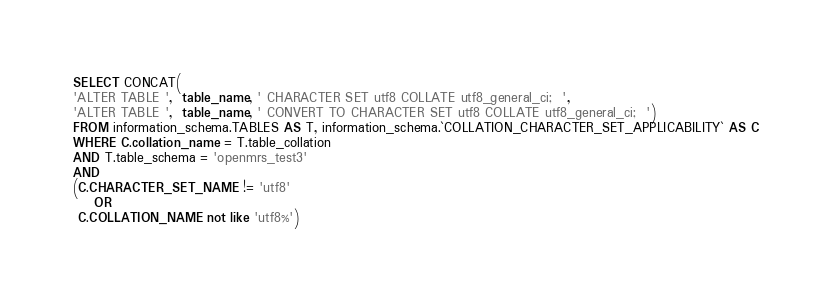<code> <loc_0><loc_0><loc_500><loc_500><_SQL_>SELECT CONCAT(
'ALTER TABLE ',  table_name, ' CHARACTER SET utf8 COLLATE utf8_general_ci;  ', 
'ALTER TABLE ',  table_name, ' CONVERT TO CHARACTER SET utf8 COLLATE utf8_general_ci;  ')
FROM information_schema.TABLES AS T, information_schema.`COLLATION_CHARACTER_SET_APPLICABILITY` AS C
WHERE C.collation_name = T.table_collation
AND T.table_schema = 'openmrs_test3'
AND
(C.CHARACTER_SET_NAME != 'utf8'
    OR
 C.COLLATION_NAME not like 'utf8%')</code> 